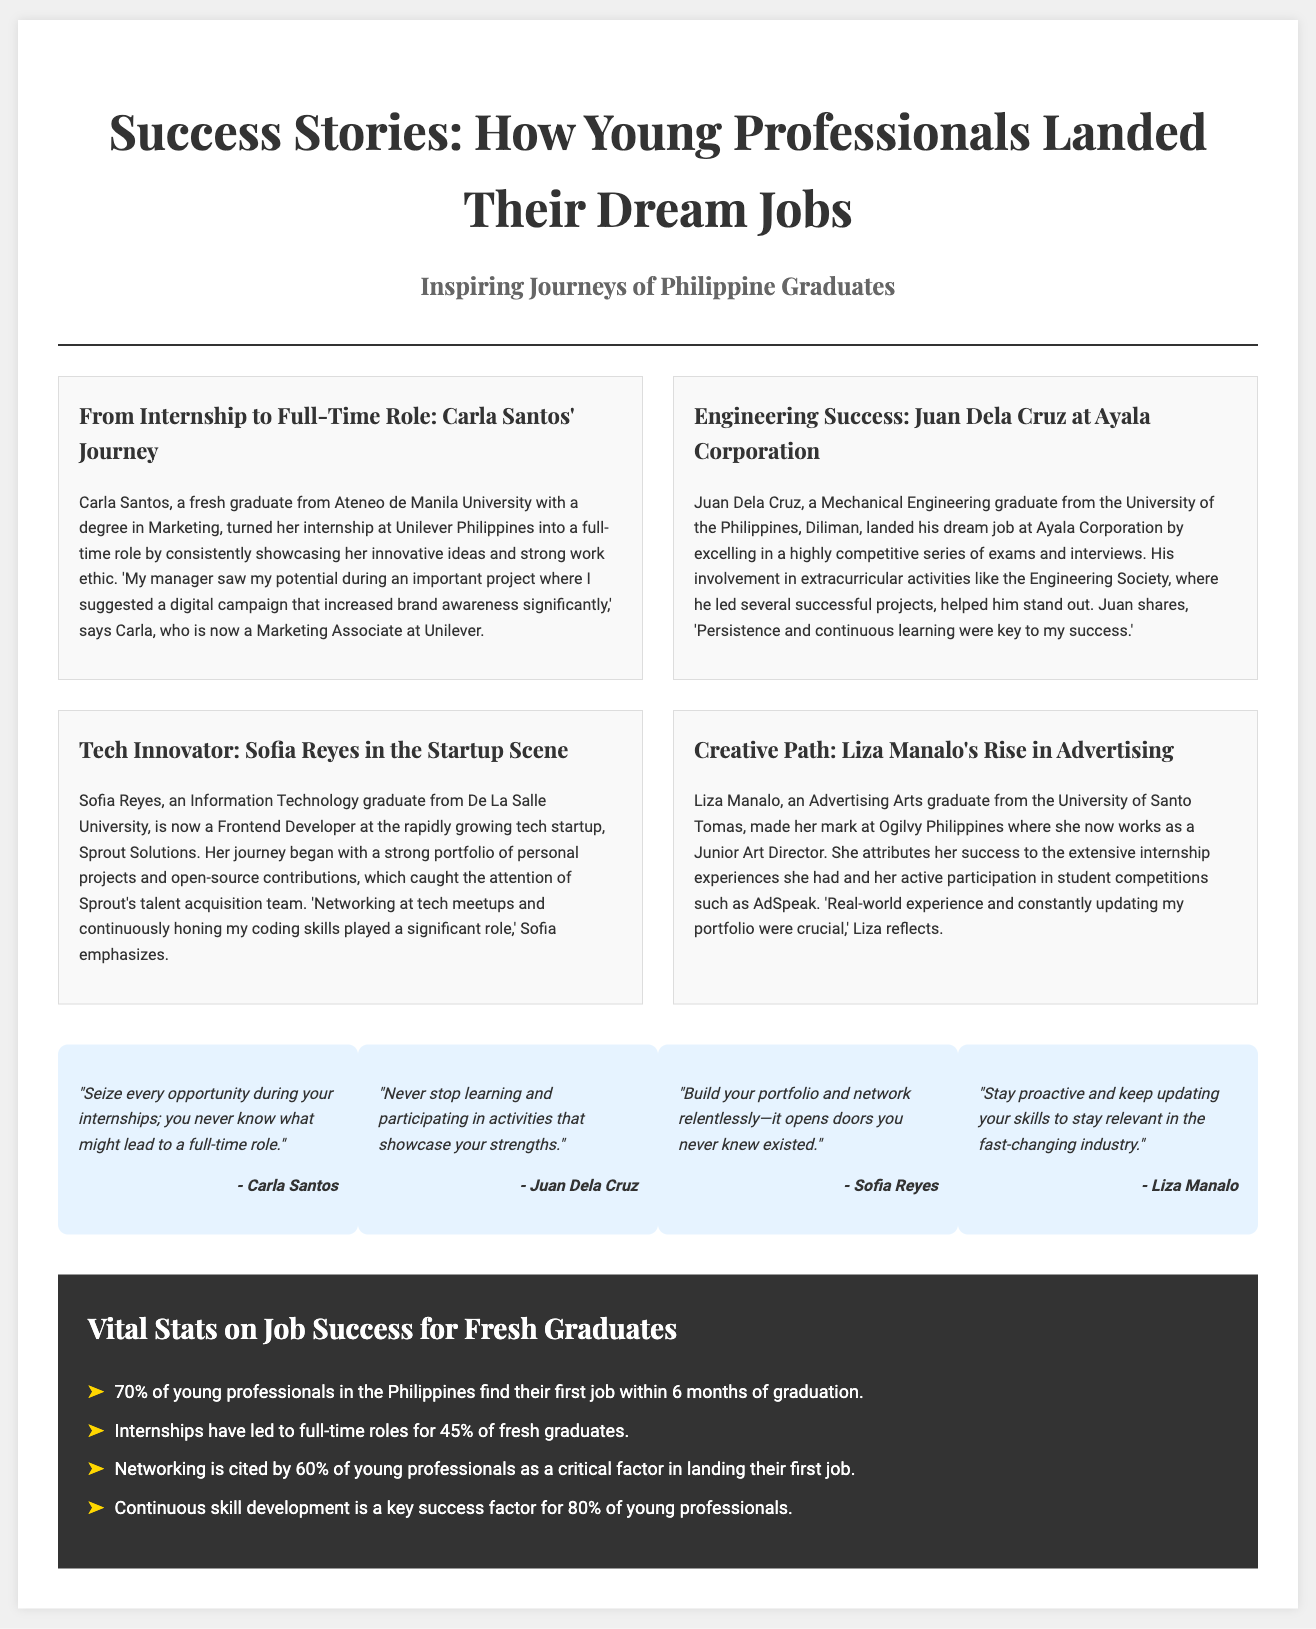What is the title of the article? The title of the article is located at the top of the newspaper layout, presenting the main theme of the content.
Answer: Success Stories: How Young Professionals Landed Their Dream Jobs Who is the author of the journey about Carla Santos? The document provides information about Carla Santos's journey but does not mention an author, focusing instead on the individual's success.
Answer: Carla Santos What company did Juan Dela Cruz join? The article about Juan Dela Cruz specifies the company he joined after graduation.
Answer: Ayala Corporation What percentage of young professionals find their first job within 6 months? This statistic is highlighted in the 'Vital Stats on Job Success for Fresh Graduates' section of the document.
Answer: 70% What key factor did 60% of young professionals cite for landing their first job? The document notes that networking is crucial for young professionals in successfully securing their first job.
Answer: Networking How did Sofia Reyes stand out to Sprout Solutions? The passage about Sofia Reyes explains how she gained attention through her ability to create a strong portfolio and contributions.
Answer: Strong portfolio What was Liza Manalo's field of study? The document states her educational background at the University of Santo Tomas, detailing her specific degree.
Answer: Advertising Arts What crucial skills should young professionals continuously develop according to Liza? The article quotes Liza on the importance of staying updated with new skills relevant to her industry.
Answer: Skills 